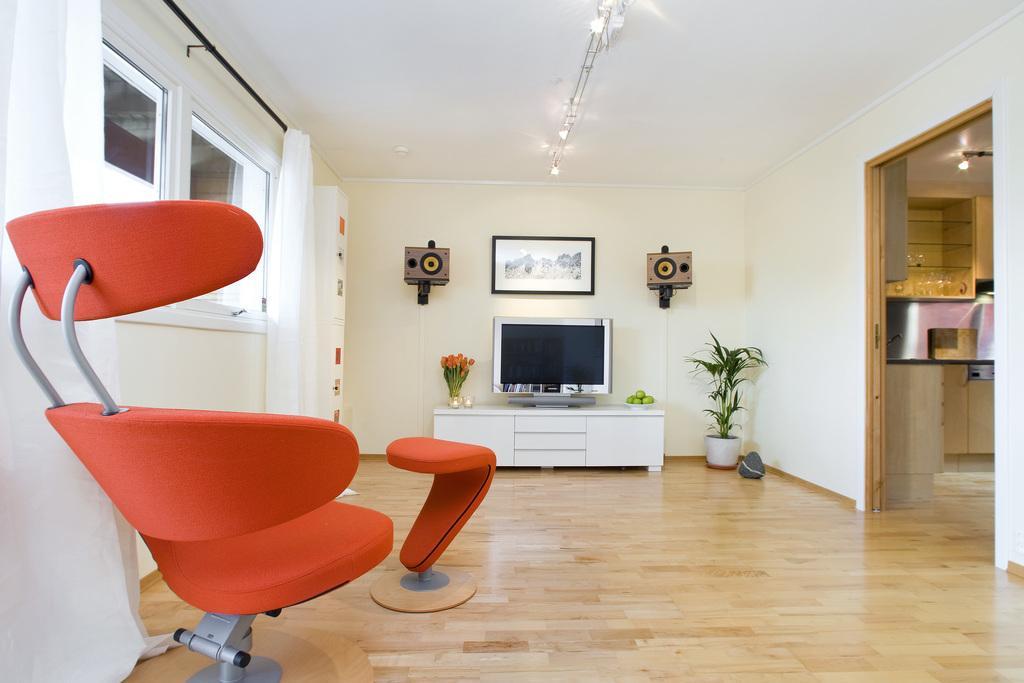Can you describe this image briefly? This image consists of a chair and a stool. At the bottom, there is a floor. In the front, we can see a TV on a cabinet. On the right, there is a potted plant. And we can see the speakers and a frame hanged to the wall. At the top, there is a roof along with the light. On the left, there are windows along with the curtains. On the right, it looks like a kitchen. 